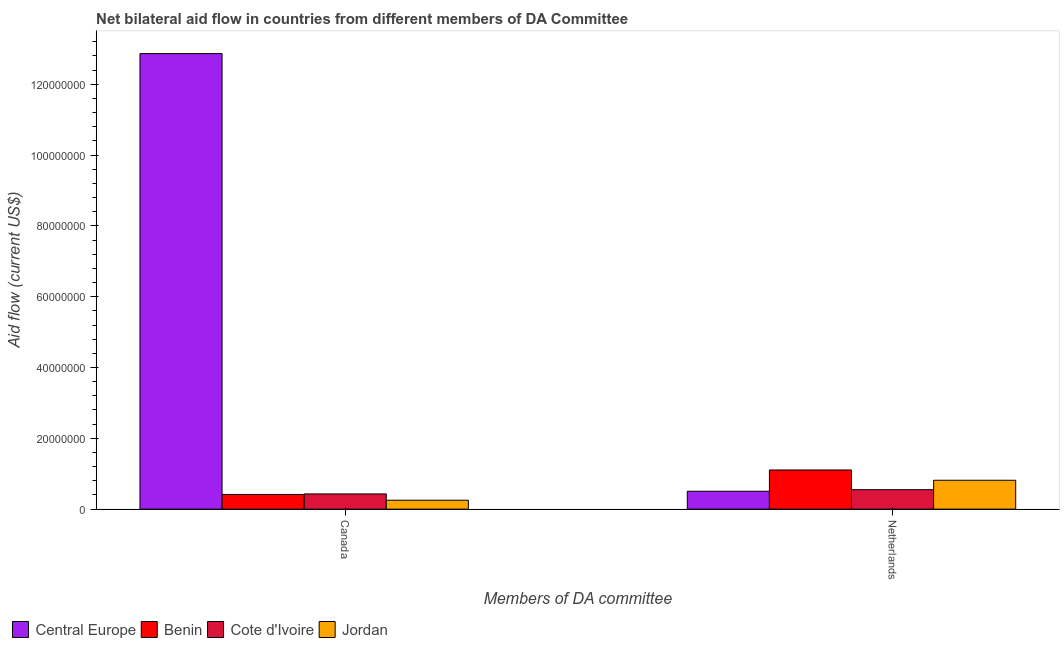How many different coloured bars are there?
Offer a very short reply. 4. How many groups of bars are there?
Your answer should be compact. 2. How many bars are there on the 2nd tick from the right?
Make the answer very short. 4. What is the amount of aid given by netherlands in Cote d'Ivoire?
Your answer should be very brief. 5.50e+06. Across all countries, what is the maximum amount of aid given by canada?
Your answer should be compact. 1.29e+08. Across all countries, what is the minimum amount of aid given by canada?
Provide a short and direct response. 2.52e+06. In which country was the amount of aid given by canada maximum?
Provide a succinct answer. Central Europe. In which country was the amount of aid given by netherlands minimum?
Provide a succinct answer. Central Europe. What is the total amount of aid given by netherlands in the graph?
Make the answer very short. 2.98e+07. What is the difference between the amount of aid given by netherlands in Cote d'Ivoire and that in Central Europe?
Offer a terse response. 4.40e+05. What is the difference between the amount of aid given by netherlands in Cote d'Ivoire and the amount of aid given by canada in Jordan?
Ensure brevity in your answer.  2.98e+06. What is the average amount of aid given by netherlands per country?
Offer a very short reply. 7.44e+06. What is the difference between the amount of aid given by netherlands and amount of aid given by canada in Central Europe?
Give a very brief answer. -1.24e+08. What is the ratio of the amount of aid given by canada in Benin to that in Jordan?
Provide a succinct answer. 1.65. Is the amount of aid given by netherlands in Benin less than that in Central Europe?
Offer a terse response. No. What does the 1st bar from the left in Canada represents?
Your answer should be compact. Central Europe. What does the 3rd bar from the right in Canada represents?
Provide a short and direct response. Benin. How many countries are there in the graph?
Offer a very short reply. 4. How are the legend labels stacked?
Your answer should be very brief. Horizontal. What is the title of the graph?
Ensure brevity in your answer.  Net bilateral aid flow in countries from different members of DA Committee. What is the label or title of the X-axis?
Your response must be concise. Members of DA committee. What is the label or title of the Y-axis?
Your answer should be compact. Aid flow (current US$). What is the Aid flow (current US$) in Central Europe in Canada?
Give a very brief answer. 1.29e+08. What is the Aid flow (current US$) of Benin in Canada?
Provide a short and direct response. 4.15e+06. What is the Aid flow (current US$) of Cote d'Ivoire in Canada?
Provide a short and direct response. 4.30e+06. What is the Aid flow (current US$) in Jordan in Canada?
Provide a succinct answer. 2.52e+06. What is the Aid flow (current US$) in Central Europe in Netherlands?
Your answer should be compact. 5.06e+06. What is the Aid flow (current US$) of Benin in Netherlands?
Your answer should be compact. 1.11e+07. What is the Aid flow (current US$) of Cote d'Ivoire in Netherlands?
Your answer should be very brief. 5.50e+06. What is the Aid flow (current US$) in Jordan in Netherlands?
Offer a terse response. 8.16e+06. Across all Members of DA committee, what is the maximum Aid flow (current US$) of Central Europe?
Ensure brevity in your answer.  1.29e+08. Across all Members of DA committee, what is the maximum Aid flow (current US$) of Benin?
Offer a terse response. 1.11e+07. Across all Members of DA committee, what is the maximum Aid flow (current US$) of Cote d'Ivoire?
Ensure brevity in your answer.  5.50e+06. Across all Members of DA committee, what is the maximum Aid flow (current US$) of Jordan?
Provide a succinct answer. 8.16e+06. Across all Members of DA committee, what is the minimum Aid flow (current US$) in Central Europe?
Provide a short and direct response. 5.06e+06. Across all Members of DA committee, what is the minimum Aid flow (current US$) in Benin?
Offer a terse response. 4.15e+06. Across all Members of DA committee, what is the minimum Aid flow (current US$) of Cote d'Ivoire?
Your response must be concise. 4.30e+06. Across all Members of DA committee, what is the minimum Aid flow (current US$) of Jordan?
Give a very brief answer. 2.52e+06. What is the total Aid flow (current US$) in Central Europe in the graph?
Offer a terse response. 1.34e+08. What is the total Aid flow (current US$) of Benin in the graph?
Your answer should be compact. 1.52e+07. What is the total Aid flow (current US$) in Cote d'Ivoire in the graph?
Your response must be concise. 9.80e+06. What is the total Aid flow (current US$) of Jordan in the graph?
Offer a very short reply. 1.07e+07. What is the difference between the Aid flow (current US$) in Central Europe in Canada and that in Netherlands?
Your answer should be compact. 1.24e+08. What is the difference between the Aid flow (current US$) of Benin in Canada and that in Netherlands?
Provide a short and direct response. -6.91e+06. What is the difference between the Aid flow (current US$) in Cote d'Ivoire in Canada and that in Netherlands?
Provide a succinct answer. -1.20e+06. What is the difference between the Aid flow (current US$) in Jordan in Canada and that in Netherlands?
Your answer should be very brief. -5.64e+06. What is the difference between the Aid flow (current US$) in Central Europe in Canada and the Aid flow (current US$) in Benin in Netherlands?
Keep it short and to the point. 1.18e+08. What is the difference between the Aid flow (current US$) in Central Europe in Canada and the Aid flow (current US$) in Cote d'Ivoire in Netherlands?
Provide a succinct answer. 1.23e+08. What is the difference between the Aid flow (current US$) in Central Europe in Canada and the Aid flow (current US$) in Jordan in Netherlands?
Make the answer very short. 1.20e+08. What is the difference between the Aid flow (current US$) of Benin in Canada and the Aid flow (current US$) of Cote d'Ivoire in Netherlands?
Your answer should be compact. -1.35e+06. What is the difference between the Aid flow (current US$) of Benin in Canada and the Aid flow (current US$) of Jordan in Netherlands?
Offer a very short reply. -4.01e+06. What is the difference between the Aid flow (current US$) in Cote d'Ivoire in Canada and the Aid flow (current US$) in Jordan in Netherlands?
Provide a short and direct response. -3.86e+06. What is the average Aid flow (current US$) of Central Europe per Members of DA committee?
Keep it short and to the point. 6.68e+07. What is the average Aid flow (current US$) in Benin per Members of DA committee?
Your answer should be very brief. 7.60e+06. What is the average Aid flow (current US$) of Cote d'Ivoire per Members of DA committee?
Your answer should be compact. 4.90e+06. What is the average Aid flow (current US$) in Jordan per Members of DA committee?
Your response must be concise. 5.34e+06. What is the difference between the Aid flow (current US$) in Central Europe and Aid flow (current US$) in Benin in Canada?
Keep it short and to the point. 1.24e+08. What is the difference between the Aid flow (current US$) in Central Europe and Aid flow (current US$) in Cote d'Ivoire in Canada?
Your answer should be compact. 1.24e+08. What is the difference between the Aid flow (current US$) in Central Europe and Aid flow (current US$) in Jordan in Canada?
Make the answer very short. 1.26e+08. What is the difference between the Aid flow (current US$) of Benin and Aid flow (current US$) of Cote d'Ivoire in Canada?
Keep it short and to the point. -1.50e+05. What is the difference between the Aid flow (current US$) in Benin and Aid flow (current US$) in Jordan in Canada?
Provide a succinct answer. 1.63e+06. What is the difference between the Aid flow (current US$) in Cote d'Ivoire and Aid flow (current US$) in Jordan in Canada?
Make the answer very short. 1.78e+06. What is the difference between the Aid flow (current US$) of Central Europe and Aid flow (current US$) of Benin in Netherlands?
Ensure brevity in your answer.  -6.00e+06. What is the difference between the Aid flow (current US$) in Central Europe and Aid flow (current US$) in Cote d'Ivoire in Netherlands?
Your response must be concise. -4.40e+05. What is the difference between the Aid flow (current US$) in Central Europe and Aid flow (current US$) in Jordan in Netherlands?
Provide a succinct answer. -3.10e+06. What is the difference between the Aid flow (current US$) in Benin and Aid flow (current US$) in Cote d'Ivoire in Netherlands?
Make the answer very short. 5.56e+06. What is the difference between the Aid flow (current US$) of Benin and Aid flow (current US$) of Jordan in Netherlands?
Give a very brief answer. 2.90e+06. What is the difference between the Aid flow (current US$) of Cote d'Ivoire and Aid flow (current US$) of Jordan in Netherlands?
Your answer should be compact. -2.66e+06. What is the ratio of the Aid flow (current US$) in Central Europe in Canada to that in Netherlands?
Provide a short and direct response. 25.42. What is the ratio of the Aid flow (current US$) in Benin in Canada to that in Netherlands?
Your answer should be very brief. 0.38. What is the ratio of the Aid flow (current US$) in Cote d'Ivoire in Canada to that in Netherlands?
Give a very brief answer. 0.78. What is the ratio of the Aid flow (current US$) of Jordan in Canada to that in Netherlands?
Your answer should be compact. 0.31. What is the difference between the highest and the second highest Aid flow (current US$) in Central Europe?
Ensure brevity in your answer.  1.24e+08. What is the difference between the highest and the second highest Aid flow (current US$) in Benin?
Your answer should be compact. 6.91e+06. What is the difference between the highest and the second highest Aid flow (current US$) in Cote d'Ivoire?
Provide a succinct answer. 1.20e+06. What is the difference between the highest and the second highest Aid flow (current US$) of Jordan?
Offer a very short reply. 5.64e+06. What is the difference between the highest and the lowest Aid flow (current US$) in Central Europe?
Keep it short and to the point. 1.24e+08. What is the difference between the highest and the lowest Aid flow (current US$) of Benin?
Provide a short and direct response. 6.91e+06. What is the difference between the highest and the lowest Aid flow (current US$) of Cote d'Ivoire?
Offer a terse response. 1.20e+06. What is the difference between the highest and the lowest Aid flow (current US$) in Jordan?
Your answer should be compact. 5.64e+06. 